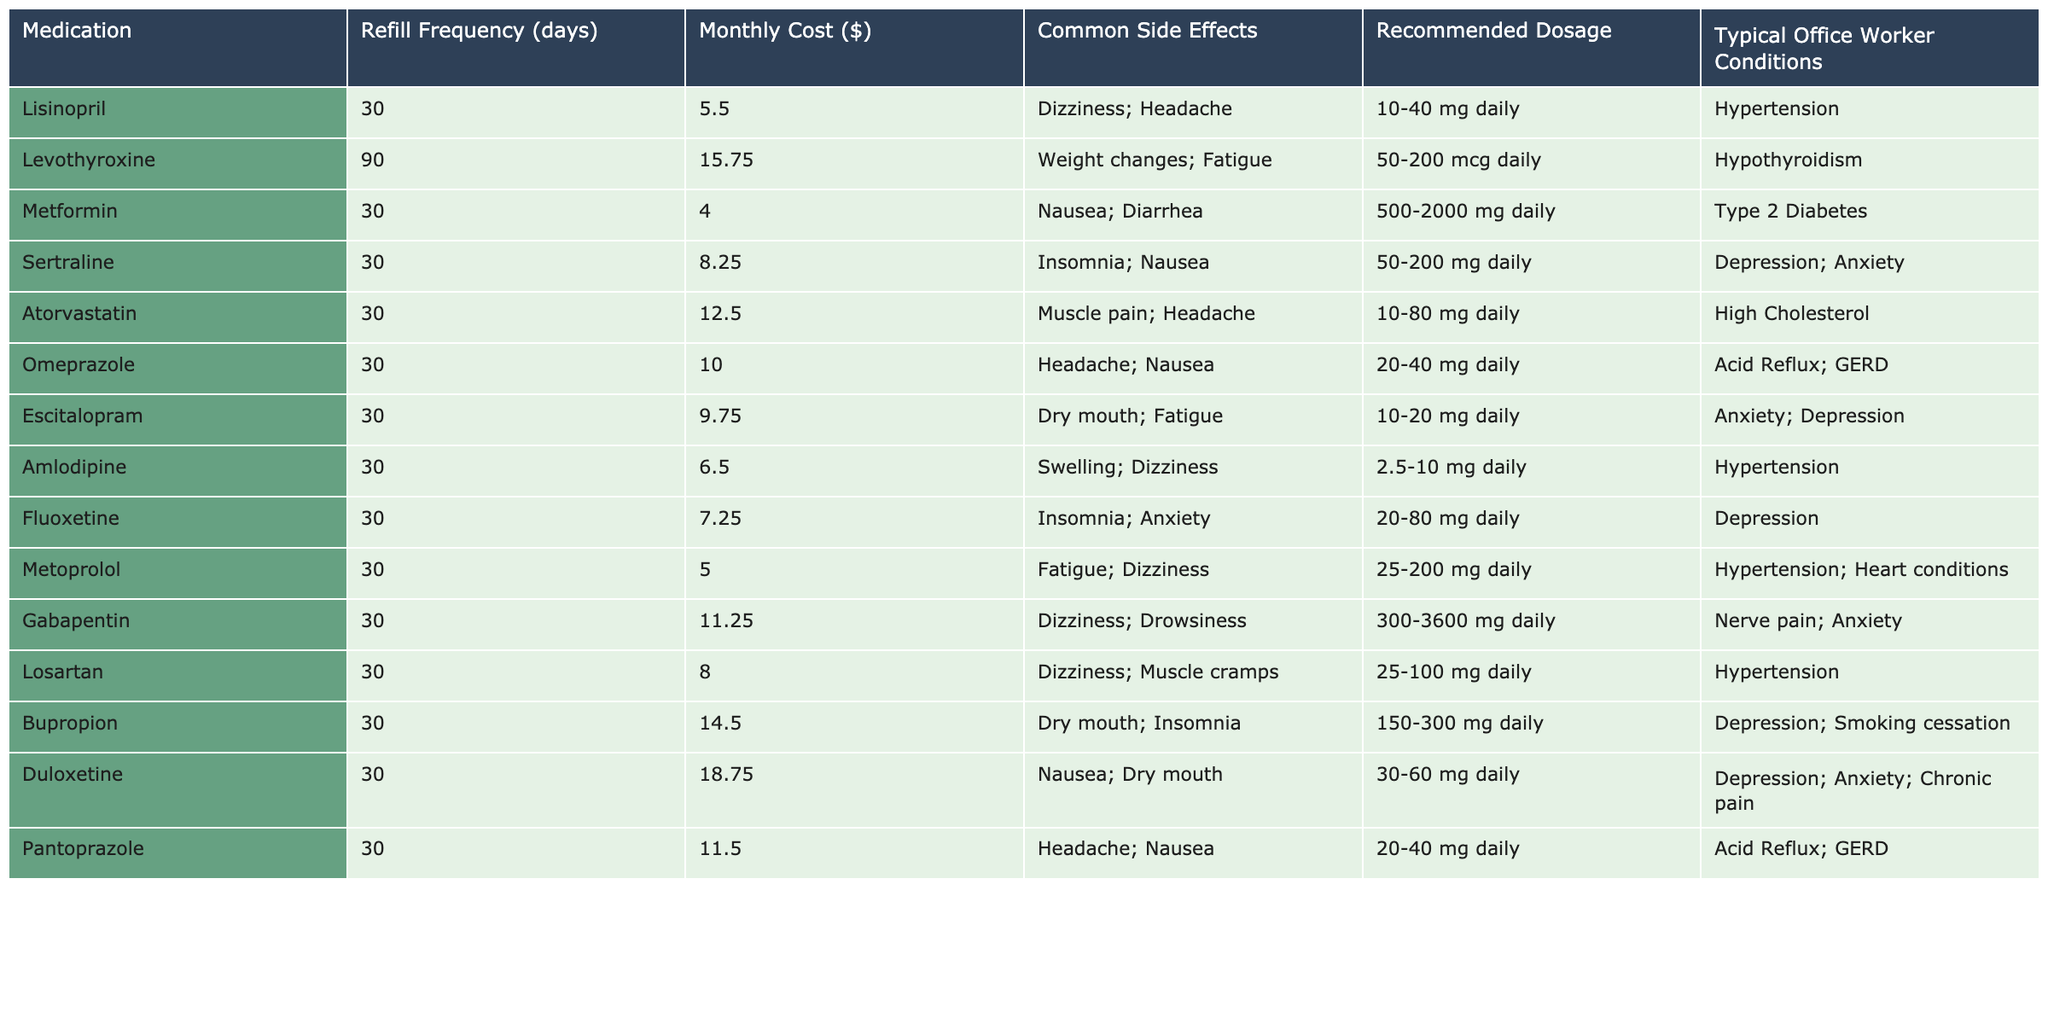What is the refill frequency for Metformin? The table lists the refill frequency under the "Refill Frequency (days)" column. For Metformin, it is specified as 30 days.
Answer: 30 days What is the monthly cost of Duloxetine? To find the monthly cost of Duloxetine, refer to the "Monthly Cost ($)" column. Duloxetine is listed with a cost of 18.75 dollars.
Answer: 18.75 dollars How many medications have a refill frequency of 30 days? Count the medications under the "Medication" column that have a refill frequency of 30 days, which are Lisinopril, Metformin, Sertraline, Atorvastatin, Omeprazole, Escitalopram, Amlodipine, Fluoxetine, Metoprolol, Gabapentin, Losartan, Bupropion, Duloxetine. This results in a total of 13 medications.
Answer: 13 medications Which medication has the highest monthly cost? Examine the "Monthly Cost ($)" column to identify the highest value. Duloxetine has the highest cost listed, which is 18.75 dollars.
Answer: Duloxetine Are there any medications for hypertension that have side effects of dizziness? Check the "Medication" column along with the "Common Side Effects" column to find medications used for hypertension with dizziness as a side effect. Lisinopril, Amlodipine, and Losartan meet this criterion.
Answer: Yes What is the average monthly cost of medications that have a refill frequency of 30 days? First, identify the monthly costs of all medications with a 30-day refill frequency: 5.50, 4.00, 8.25, 12.50, 10.00, 9.75, 6.50, 7.25, 5.00, 11.25, 8.00, 14.50, 18.75. The total is 8.58 dollars, and there are 13 medications, therefore, the average cost is approximately 8.58 dollars.
Answer: 8.58 dollars Which condition is most commonly associated with the medications listed? Review the "Typical Office Worker Conditions" column and identify the conditions associated with the most medications. Hypertension is mentioned for 4 medications (Lisinopril, Amlodipine, Metoprolol, Losartan), so it is the most common condition.
Answer: Hypertension How many medications have both a 30-day refill frequency and common side effects of nausea? Identify medications that have a refill frequency of 30 days and also mention nausea in their side effects. Both Omeprazole and Fluoxetine meet this criteria.
Answer: 2 medications Is there any medication with a monthly cost below 5 dollars? The "Monthly Cost ($)" column is examined for values below 5 dollars. Metformin is listed at 4.00 dollars, confirming that there is a medication under this price.
Answer: Yes What is the total number of medications listed in the table? Count all medications in the "Medication" column; there are 13 medications listed.
Answer: 13 medications 